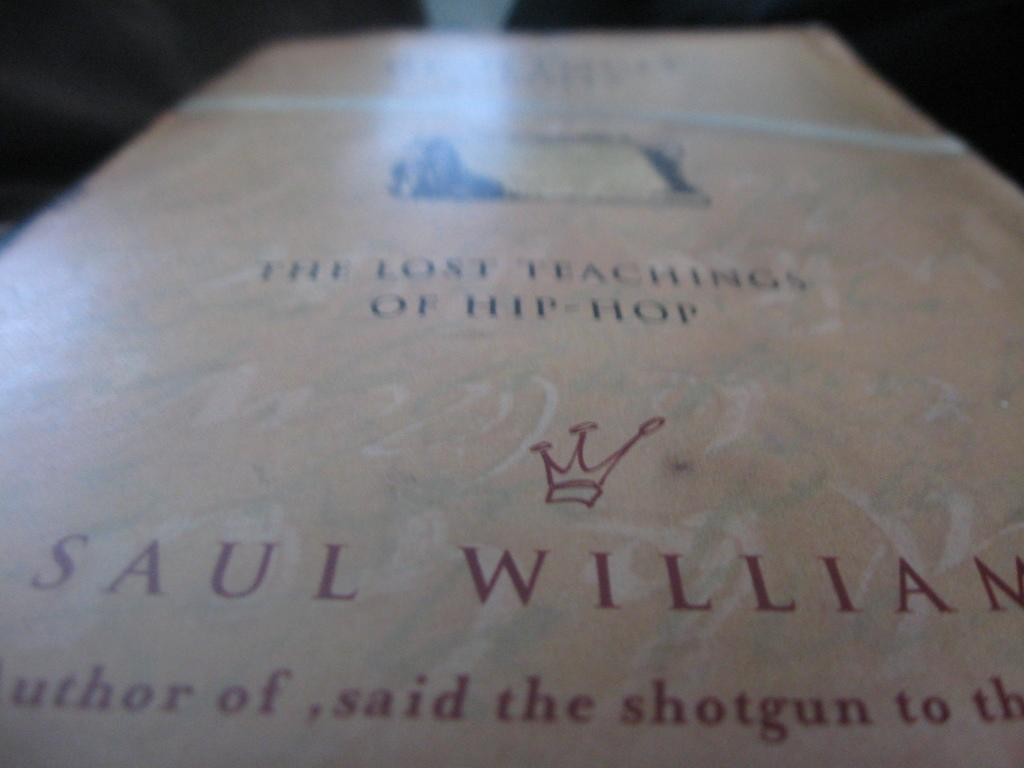<image>
Render a clear and concise summary of the photo. a copy of the book "The lost teachings of hip hop" by Saul William. 